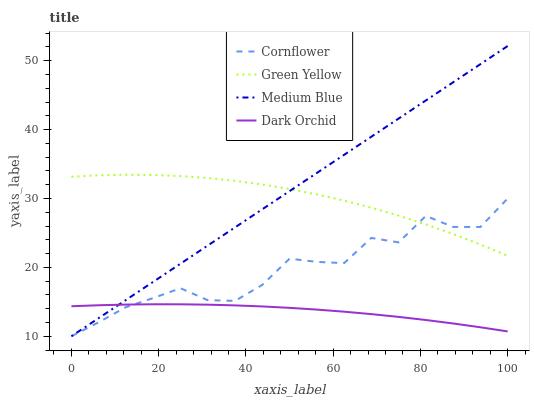Does Green Yellow have the minimum area under the curve?
Answer yes or no. No. Does Green Yellow have the maximum area under the curve?
Answer yes or no. No. Is Green Yellow the smoothest?
Answer yes or no. No. Is Green Yellow the roughest?
Answer yes or no. No. Does Green Yellow have the lowest value?
Answer yes or no. No. Does Green Yellow have the highest value?
Answer yes or no. No. Is Dark Orchid less than Green Yellow?
Answer yes or no. Yes. Is Green Yellow greater than Dark Orchid?
Answer yes or no. Yes. Does Dark Orchid intersect Green Yellow?
Answer yes or no. No. 